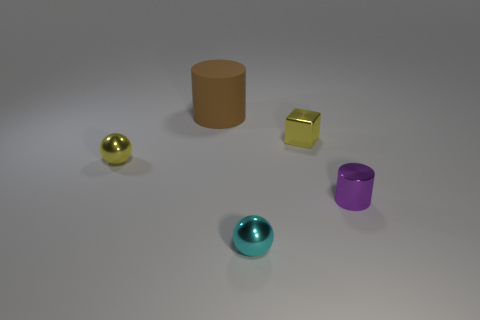What are the objects in this image used for? The objects in the image don't seem to have a specific use; they resemble geometric shapes often used for visual or material studies in 3D modeling and rendering demonstrations. 